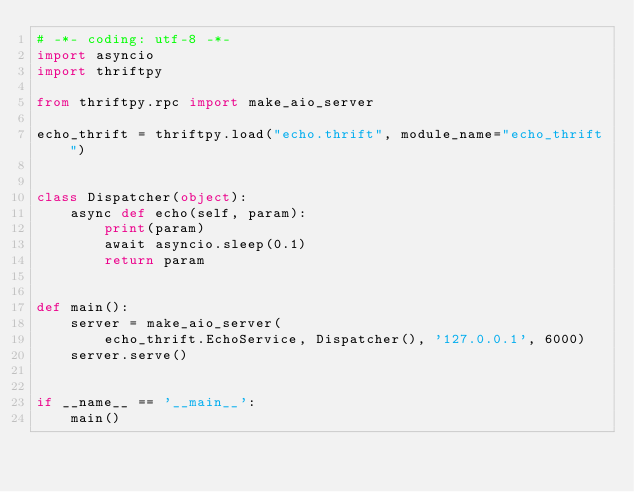Convert code to text. <code><loc_0><loc_0><loc_500><loc_500><_Python_># -*- coding: utf-8 -*-
import asyncio
import thriftpy

from thriftpy.rpc import make_aio_server

echo_thrift = thriftpy.load("echo.thrift", module_name="echo_thrift")


class Dispatcher(object):
    async def echo(self, param):
        print(param)
        await asyncio.sleep(0.1)
        return param


def main():
    server = make_aio_server(
        echo_thrift.EchoService, Dispatcher(), '127.0.0.1', 6000)
    server.serve()


if __name__ == '__main__':
    main()
</code> 